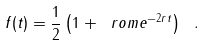Convert formula to latex. <formula><loc_0><loc_0><loc_500><loc_500>f ( t ) = \frac { 1 } { 2 } \left ( 1 + \ r o m e ^ { - 2 r t } \right ) \ .</formula> 